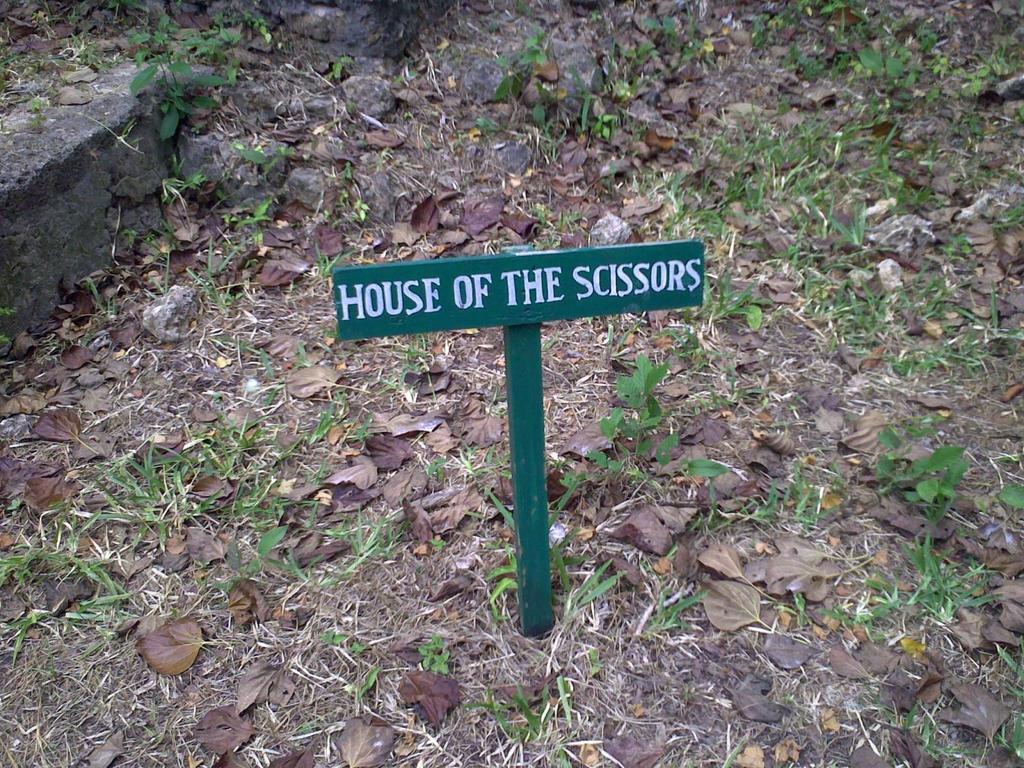In one or two sentences, can you explain what this image depicts? In this image there is a board with some text on it. At the bottom of the image there is grass and leaves on the surface. 